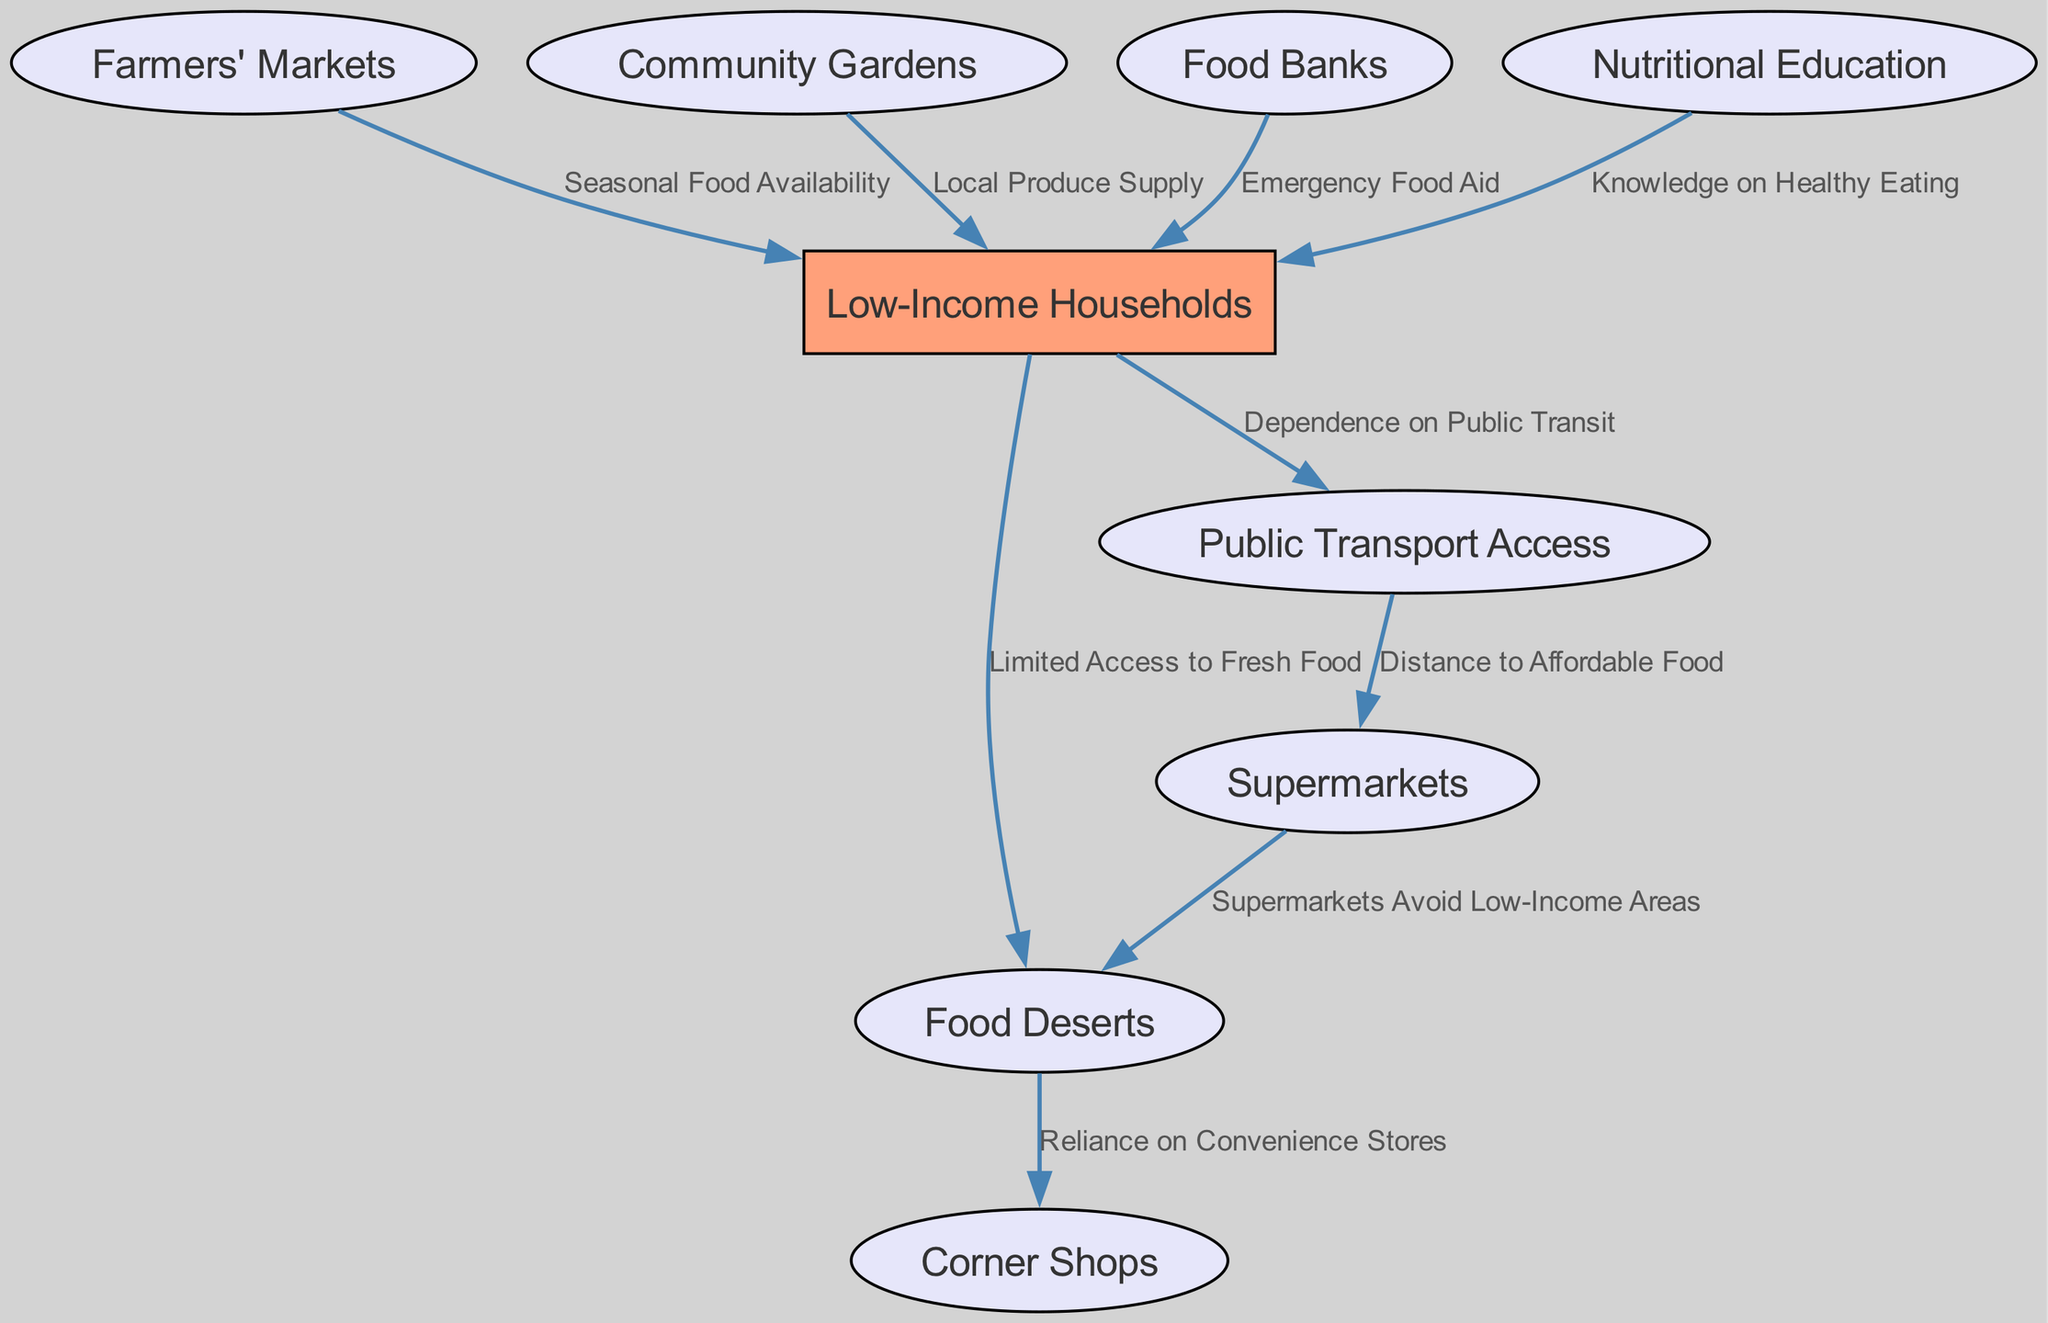What's the total number of nodes in the diagram? The diagram contains different entities that have been defined as nodes. By counting each unique entry within the "nodes" section of the provided data, we find there are 9 nodes listed.
Answer: 9 What does the arrow from food deserts to corner shops indicate? The edge specifies a relationship where food deserts lead to increased reliance on corner shops, meaning residents in food deserts frequently depend on corner shops for their food needs. This flow establishes a direct connection described as "Reliance on Convenience Stores."
Answer: Reliance on Convenience Stores Which node has a direct link to low-income households providing local produce supply? The node labeled "Community Gardens" has a direct edge pointing to "Low-Income Households." The label on this edge indicates that community gardens supply fresh produce to these households.
Answer: Community Gardens How many edges are connected to low-income households? By examining the connections originating from the "Low-Income Households" node, there are 5 distinct edges leading to other nodes, which show various relationships such as limited access and nutritional education.
Answer: 5 What role do nutritional education and food banks play in supporting low-income households? Nutritional education increases knowledge about healthy eating, which can affect food choices, while food banks provide emergency food aid, both targeting the needs of low-income households and addressing food accessibility. Together, they create a dual support system.
Answer: Dual support system How do supermarkets' locations relate to low-income neighborhoods? The diagram indicates that supermarkets tend to avoid low-income areas, which contributes to the existence of food deserts, creating a cycle of limited access to affordable, fresh food for these communities.
Answer: Avoid low-income areas What is the label on the edge connecting public transport to supermarkets? The edge between "Public Transport Access" and "Supermarkets" is labeled as "Distance to Affordable Food." This indicates that the distance to supermarkets affects the availability of affordable food for low-income households reliant on public transport.
Answer: Distance to Affordable Food Which factors contribute to creating food deserts as indicated in the diagram? The diagram shows that limited access to fresh food from low-income households and the avoidance of supermarkets creates food deserts. Thus, both the lack of fresh food access and supermarket presence directly contribute to this issue.
Answer: Limited access and supermarket avoidance 